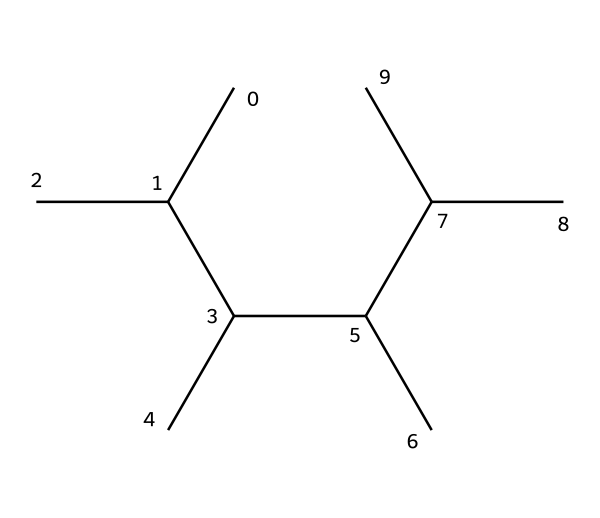What is the general formula for the polymer represented by this SMILES? The polymer structure shown suggests it is a type of alkane, specifically polyethylene, which follows the general formula CnH2n+2. So, the general formula for this SMILES representation is CnH2n where n corresponds to the number of carbon atoms in the chain.
Answer: CnH2n How many carbon atoms are in the structure? Counting the 'C' atoms in the SMILES representation reveals multiple 'C' symbols; specifically, there are 10 carbon atoms denoted in the structure.
Answer: 10 What type of bonding is present in polyethylene? The bonds in polyethylene can be deduced from the linear chain indicated in its structure, primarily consisting of single covalent bonds between carbon and hydrogen atoms.
Answer: single covalent bonds Does this structure possess any branching? By analyzing the structure, there are branches indicated by the pattern of carbon atoms; in this case, it shows branching due to the arrangement of carbon atoms resembling an isomer of propane.
Answer: Yes What is the state of polyethylene at room temperature? Considering that polyethylene is a common thermoplastic polymer with a long chain structure, it is typically solid at room temperature.
Answer: solid What kind of polymerization does this structure represent? The structure represents addition polymerization, which occurs when many small alkene molecules (monomers) like ethylene join together without the formation of any by-products.
Answer: addition polymerization 